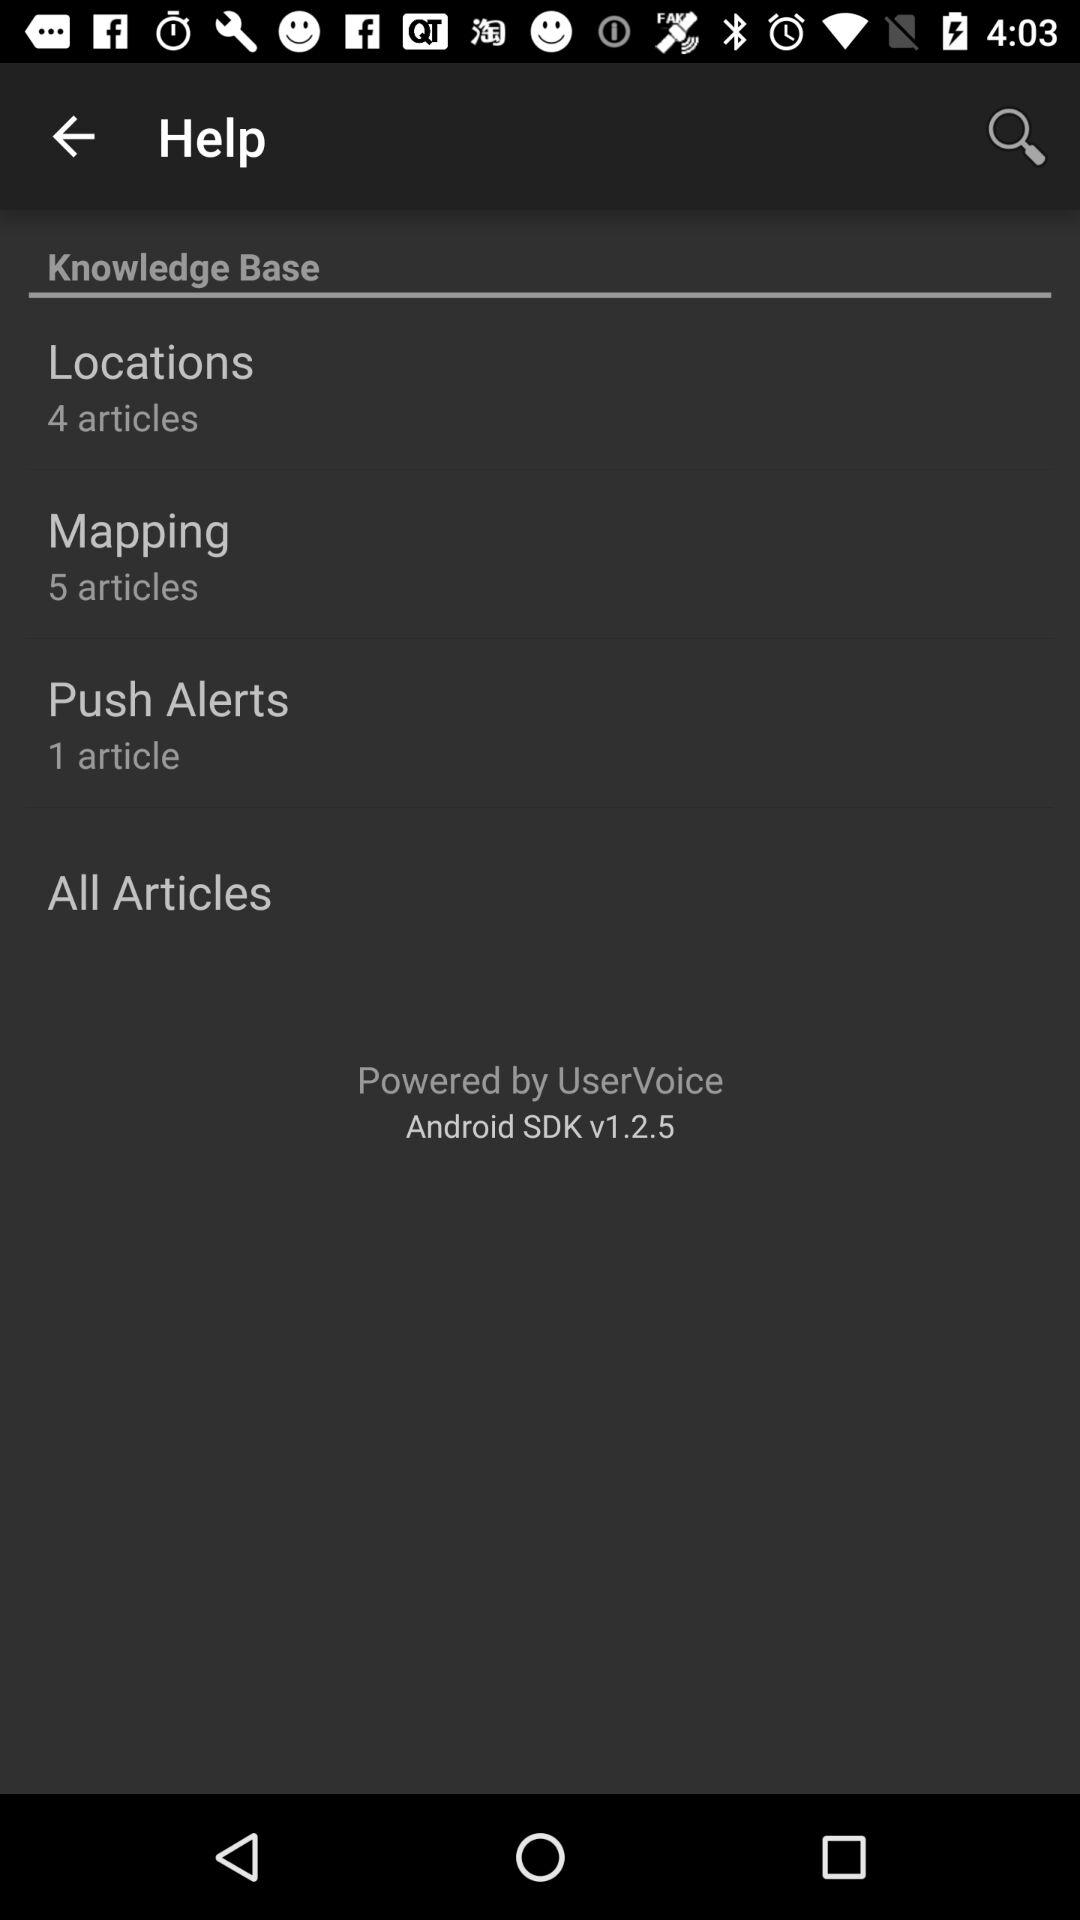How many articles in "Mapping"? There are 5 articles in "Mapping". 